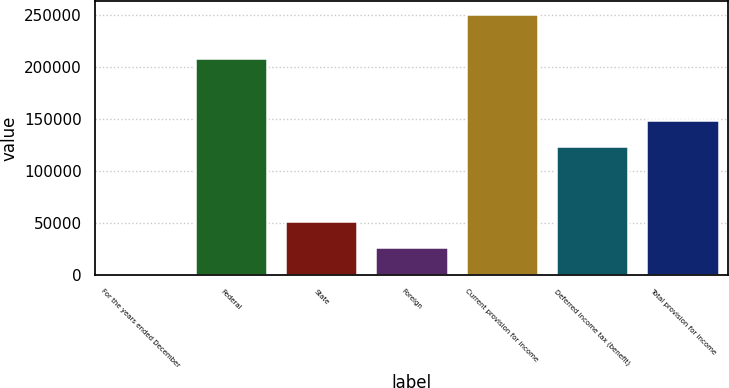Convert chart. <chart><loc_0><loc_0><loc_500><loc_500><bar_chart><fcel>For the years ended December<fcel>Federal<fcel>State<fcel>Foreign<fcel>Current provision for income<fcel>Deferred income tax (benefit)<fcel>Total provision for income<nl><fcel>2007<fcel>208754<fcel>51678.4<fcel>26842.7<fcel>250364<fcel>124276<fcel>149112<nl></chart> 